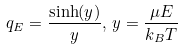<formula> <loc_0><loc_0><loc_500><loc_500>q _ { E } = \frac { \sinh ( y ) } { y } , \, y = \frac { \mu E } { k _ { B } T }</formula> 